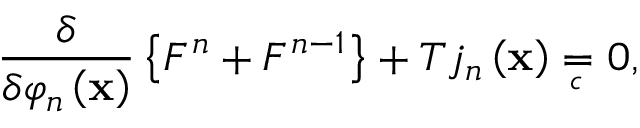Convert formula to latex. <formula><loc_0><loc_0><loc_500><loc_500>\frac { \delta } \delta \varphi _ { n } \left ( x \right ) } \left \{ F ^ { n } + F ^ { n - 1 } \right \} + T j _ { n } \left ( x \right ) _ { \, c } } \, 0 ,</formula> 